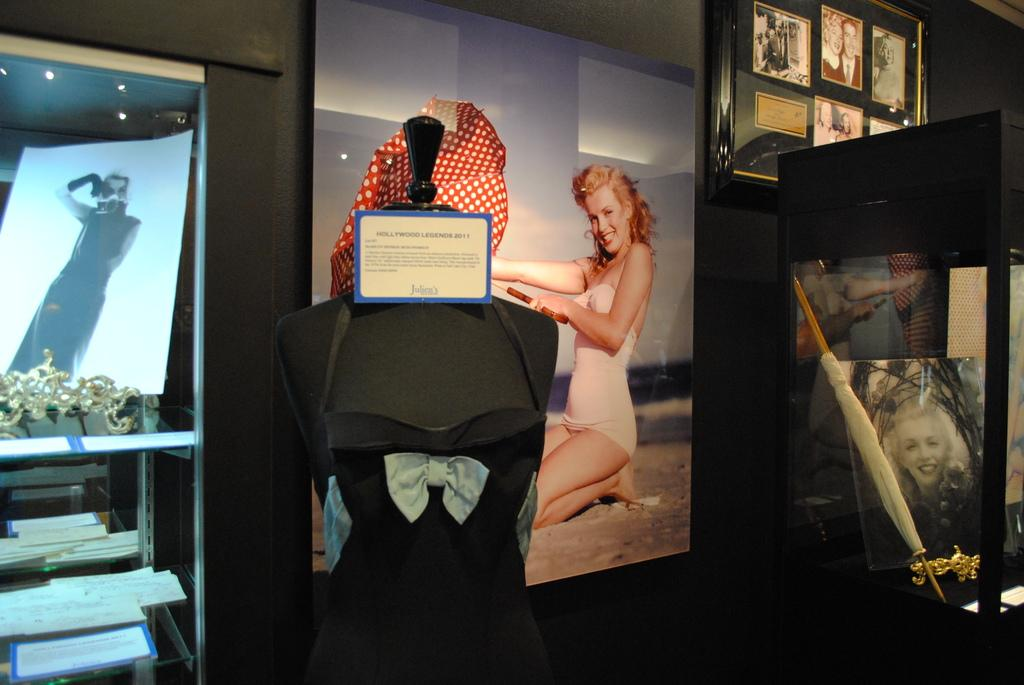What is the main subject in the image? There is a mannequin in the image. What can be seen on the left side of the image? There are objects on a shelf on the left side of the image. What is hanging on the wall in the image? There is a photo frame on the wall in the image. What type of insurance does the mannequin have in the image? There is no information about insurance in the image, as it features a mannequin and other objects. 